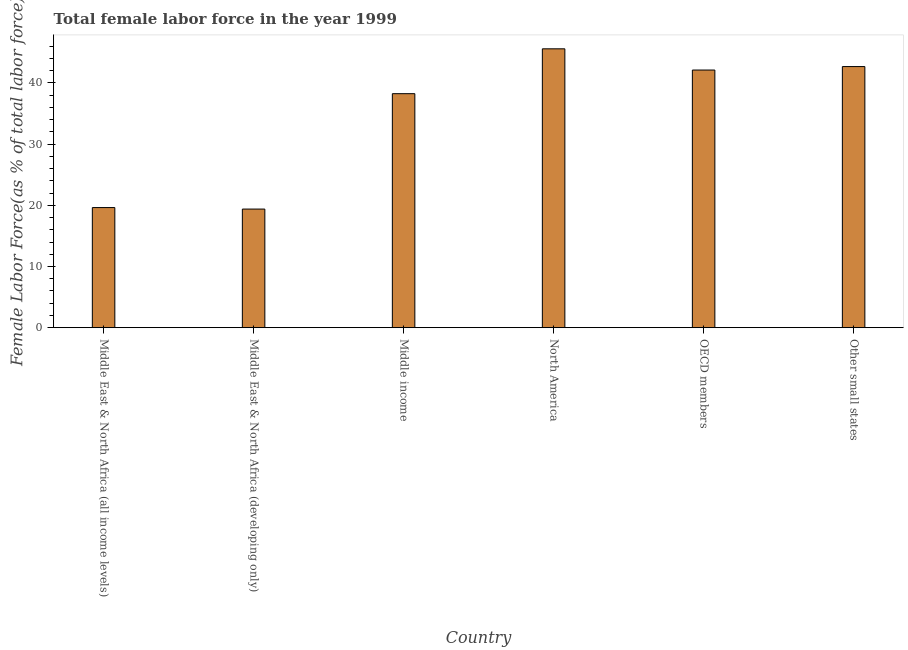Does the graph contain any zero values?
Offer a terse response. No. What is the title of the graph?
Give a very brief answer. Total female labor force in the year 1999. What is the label or title of the X-axis?
Your answer should be compact. Country. What is the label or title of the Y-axis?
Make the answer very short. Female Labor Force(as % of total labor force). What is the total female labor force in Middle East & North Africa (developing only)?
Provide a short and direct response. 19.38. Across all countries, what is the maximum total female labor force?
Give a very brief answer. 45.57. Across all countries, what is the minimum total female labor force?
Offer a very short reply. 19.38. In which country was the total female labor force maximum?
Offer a very short reply. North America. In which country was the total female labor force minimum?
Offer a terse response. Middle East & North Africa (developing only). What is the sum of the total female labor force?
Provide a succinct answer. 207.6. What is the difference between the total female labor force in Middle income and North America?
Your response must be concise. -7.33. What is the average total female labor force per country?
Your response must be concise. 34.6. What is the median total female labor force?
Make the answer very short. 40.17. What is the ratio of the total female labor force in Middle East & North Africa (developing only) to that in OECD members?
Offer a very short reply. 0.46. What is the difference between the highest and the second highest total female labor force?
Provide a short and direct response. 2.9. Is the sum of the total female labor force in Middle income and Other small states greater than the maximum total female labor force across all countries?
Your response must be concise. Yes. What is the difference between the highest and the lowest total female labor force?
Provide a short and direct response. 26.19. How many bars are there?
Make the answer very short. 6. How many countries are there in the graph?
Provide a short and direct response. 6. What is the difference between two consecutive major ticks on the Y-axis?
Your answer should be very brief. 10. What is the Female Labor Force(as % of total labor force) of Middle East & North Africa (all income levels)?
Offer a terse response. 19.63. What is the Female Labor Force(as % of total labor force) of Middle East & North Africa (developing only)?
Give a very brief answer. 19.38. What is the Female Labor Force(as % of total labor force) of Middle income?
Ensure brevity in your answer.  38.24. What is the Female Labor Force(as % of total labor force) of North America?
Your answer should be very brief. 45.57. What is the Female Labor Force(as % of total labor force) in OECD members?
Your answer should be compact. 42.1. What is the Female Labor Force(as % of total labor force) of Other small states?
Your response must be concise. 42.67. What is the difference between the Female Labor Force(as % of total labor force) in Middle East & North Africa (all income levels) and Middle East & North Africa (developing only)?
Offer a very short reply. 0.25. What is the difference between the Female Labor Force(as % of total labor force) in Middle East & North Africa (all income levels) and Middle income?
Your response must be concise. -18.61. What is the difference between the Female Labor Force(as % of total labor force) in Middle East & North Africa (all income levels) and North America?
Your answer should be compact. -25.95. What is the difference between the Female Labor Force(as % of total labor force) in Middle East & North Africa (all income levels) and OECD members?
Give a very brief answer. -22.48. What is the difference between the Female Labor Force(as % of total labor force) in Middle East & North Africa (all income levels) and Other small states?
Your answer should be compact. -23.05. What is the difference between the Female Labor Force(as % of total labor force) in Middle East & North Africa (developing only) and Middle income?
Your answer should be very brief. -18.86. What is the difference between the Female Labor Force(as % of total labor force) in Middle East & North Africa (developing only) and North America?
Provide a short and direct response. -26.19. What is the difference between the Female Labor Force(as % of total labor force) in Middle East & North Africa (developing only) and OECD members?
Keep it short and to the point. -22.72. What is the difference between the Female Labor Force(as % of total labor force) in Middle East & North Africa (developing only) and Other small states?
Make the answer very short. -23.29. What is the difference between the Female Labor Force(as % of total labor force) in Middle income and North America?
Keep it short and to the point. -7.33. What is the difference between the Female Labor Force(as % of total labor force) in Middle income and OECD members?
Give a very brief answer. -3.86. What is the difference between the Female Labor Force(as % of total labor force) in Middle income and Other small states?
Your answer should be very brief. -4.43. What is the difference between the Female Labor Force(as % of total labor force) in North America and OECD members?
Your response must be concise. 3.47. What is the difference between the Female Labor Force(as % of total labor force) in North America and Other small states?
Make the answer very short. 2.9. What is the difference between the Female Labor Force(as % of total labor force) in OECD members and Other small states?
Provide a succinct answer. -0.57. What is the ratio of the Female Labor Force(as % of total labor force) in Middle East & North Africa (all income levels) to that in Middle East & North Africa (developing only)?
Make the answer very short. 1.01. What is the ratio of the Female Labor Force(as % of total labor force) in Middle East & North Africa (all income levels) to that in Middle income?
Your response must be concise. 0.51. What is the ratio of the Female Labor Force(as % of total labor force) in Middle East & North Africa (all income levels) to that in North America?
Make the answer very short. 0.43. What is the ratio of the Female Labor Force(as % of total labor force) in Middle East & North Africa (all income levels) to that in OECD members?
Make the answer very short. 0.47. What is the ratio of the Female Labor Force(as % of total labor force) in Middle East & North Africa (all income levels) to that in Other small states?
Your response must be concise. 0.46. What is the ratio of the Female Labor Force(as % of total labor force) in Middle East & North Africa (developing only) to that in Middle income?
Give a very brief answer. 0.51. What is the ratio of the Female Labor Force(as % of total labor force) in Middle East & North Africa (developing only) to that in North America?
Keep it short and to the point. 0.42. What is the ratio of the Female Labor Force(as % of total labor force) in Middle East & North Africa (developing only) to that in OECD members?
Give a very brief answer. 0.46. What is the ratio of the Female Labor Force(as % of total labor force) in Middle East & North Africa (developing only) to that in Other small states?
Your answer should be very brief. 0.45. What is the ratio of the Female Labor Force(as % of total labor force) in Middle income to that in North America?
Ensure brevity in your answer.  0.84. What is the ratio of the Female Labor Force(as % of total labor force) in Middle income to that in OECD members?
Ensure brevity in your answer.  0.91. What is the ratio of the Female Labor Force(as % of total labor force) in Middle income to that in Other small states?
Provide a succinct answer. 0.9. What is the ratio of the Female Labor Force(as % of total labor force) in North America to that in OECD members?
Provide a succinct answer. 1.08. What is the ratio of the Female Labor Force(as % of total labor force) in North America to that in Other small states?
Make the answer very short. 1.07. 